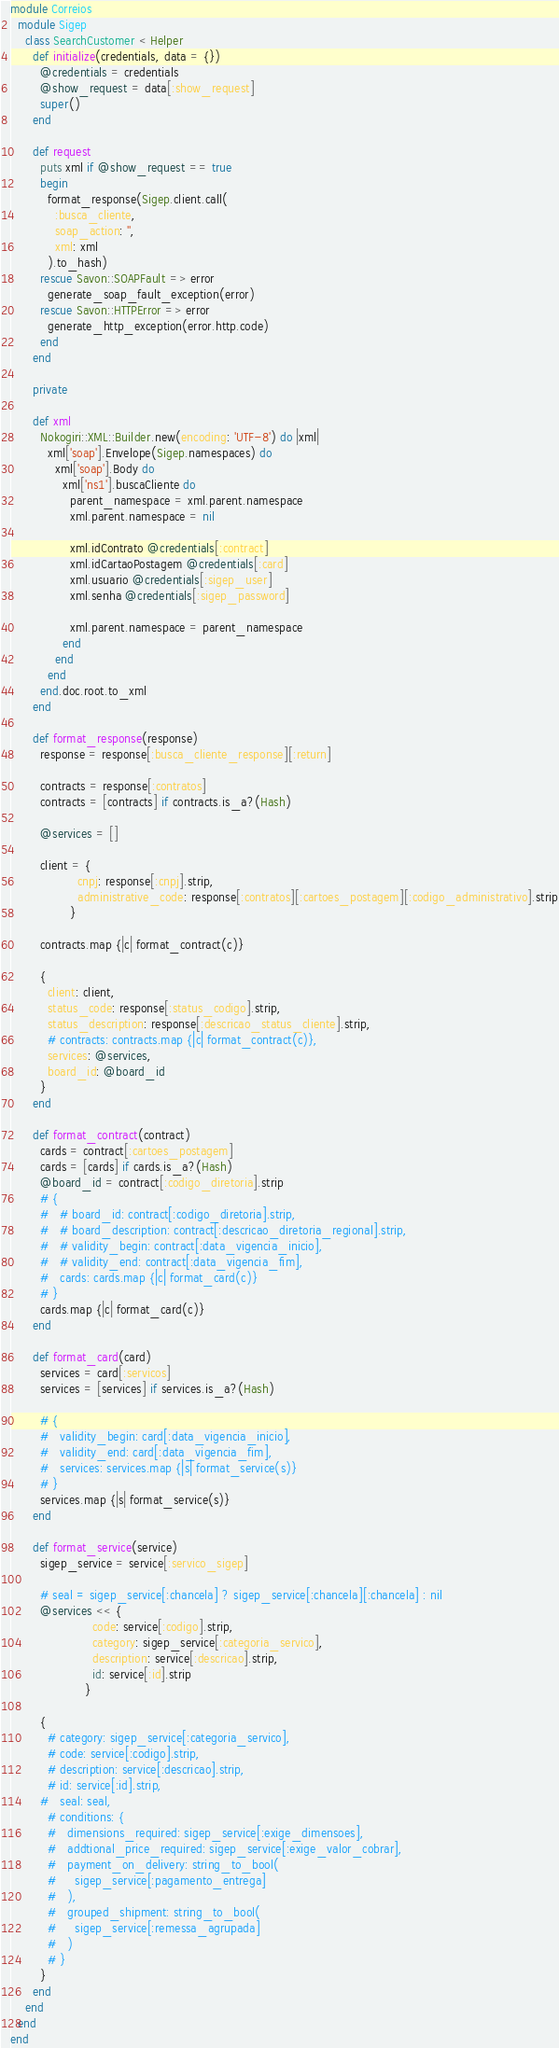<code> <loc_0><loc_0><loc_500><loc_500><_Ruby_>module Correios
  module Sigep
    class SearchCustomer < Helper
      def initialize(credentials, data = {})
        @credentials = credentials
        @show_request = data[:show_request]
        super()
      end

      def request
        puts xml if @show_request == true
        begin
          format_response(Sigep.client.call(
            :busca_cliente,
            soap_action: '',
            xml: xml
          ).to_hash)
        rescue Savon::SOAPFault => error
          generate_soap_fault_exception(error)
        rescue Savon::HTTPError => error
          generate_http_exception(error.http.code)
        end
      end

      private

      def xml
        Nokogiri::XML::Builder.new(encoding: 'UTF-8') do |xml|
          xml['soap'].Envelope(Sigep.namespaces) do
            xml['soap'].Body do
              xml['ns1'].buscaCliente do
                parent_namespace = xml.parent.namespace
                xml.parent.namespace = nil

                xml.idContrato @credentials[:contract]
                xml.idCartaoPostagem @credentials[:card]
                xml.usuario @credentials[:sigep_user]
                xml.senha @credentials[:sigep_password]

                xml.parent.namespace = parent_namespace
              end
            end
          end
        end.doc.root.to_xml
      end

      def format_response(response)
        response = response[:busca_cliente_response][:return]

        contracts = response[:contratos]
        contracts = [contracts] if contracts.is_a?(Hash)

        @services = []

        client = {
                  cnpj: response[:cnpj].strip,
                  administrative_code: response[:contratos][:cartoes_postagem][:codigo_administrativo].strip
                }

        contracts.map {|c| format_contract(c)}

        {
          client: client,
          status_code: response[:status_codigo].strip,
          status_description: response[:descricao_status_cliente].strip,
          # contracts: contracts.map {|c| format_contract(c)},
          services: @services,
          board_id: @board_id
        }
      end

      def format_contract(contract)
        cards = contract[:cartoes_postagem]
        cards = [cards] if cards.is_a?(Hash)
        @board_id = contract[:codigo_diretoria].strip
        # {
        #   # board_id: contract[:codigo_diretoria].strip,
        #   # board_description: contract[:descricao_diretoria_regional].strip,
        #   # validity_begin: contract[:data_vigencia_inicio],
        #   # validity_end: contract[:data_vigencia_fim],
        #   cards: cards.map {|c| format_card(c)}
        # }
        cards.map {|c| format_card(c)}
      end

      def format_card(card)
        services = card[:servicos]
        services = [services] if services.is_a?(Hash)
        
        # {
        #   validity_begin: card[:data_vigencia_inicio],
        #   validity_end: card[:data_vigencia_fim],
        #   services: services.map {|s| format_service(s)}
        # }
        services.map {|s| format_service(s)}
      end

      def format_service(service)
        sigep_service = service[:servico_sigep]

        # seal = sigep_service[:chancela] ? sigep_service[:chancela][:chancela] : nil
        @services << {
                      code: service[:codigo].strip,
                      category: sigep_service[:categoria_servico],
                      description: service[:descricao].strip,
                      id: service[:id].strip
                    }

        {
          # category: sigep_service[:categoria_servico],
          # code: service[:codigo].strip,
          # description: service[:descricao].strip,
          # id: service[:id].strip,
        #   seal: seal,
          # conditions: {
          #   dimensions_required: sigep_service[:exige_dimensoes],
          #   addtional_price_required: sigep_service[:exige_valor_cobrar],
          #   payment_on_delivery: string_to_bool(
          #     sigep_service[:pagamento_entrega]
          #   ),
          #   grouped_shipment: string_to_bool(
          #     sigep_service[:remessa_agrupada]
          #   )
          # }
        }
      end
    end
  end
end
</code> 